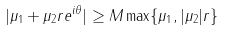<formula> <loc_0><loc_0><loc_500><loc_500>| \mu _ { 1 } + \mu _ { 2 } r e ^ { i \theta } | \geq M \max \{ \mu _ { 1 } , | \mu _ { 2 } | r \}</formula> 